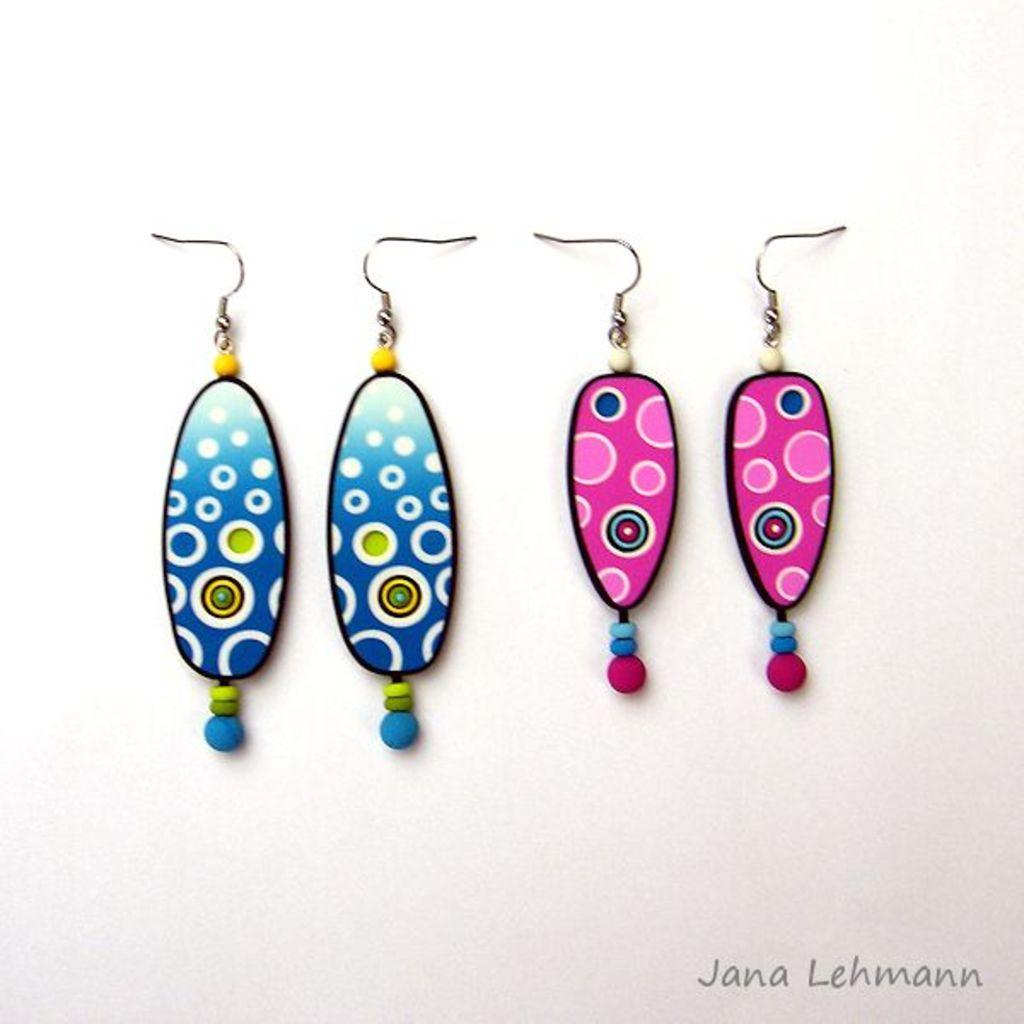What type of jewelry can be seen in the image? There are earrings placed on a surface in the image. Is there any text associated with the earrings in the image? Yes, there is some text visible at the bottom of the image. Can you describe the effect of the river on the earrings in the image? There is no river present in the image, so it is not possible to describe its effect on the earrings. 